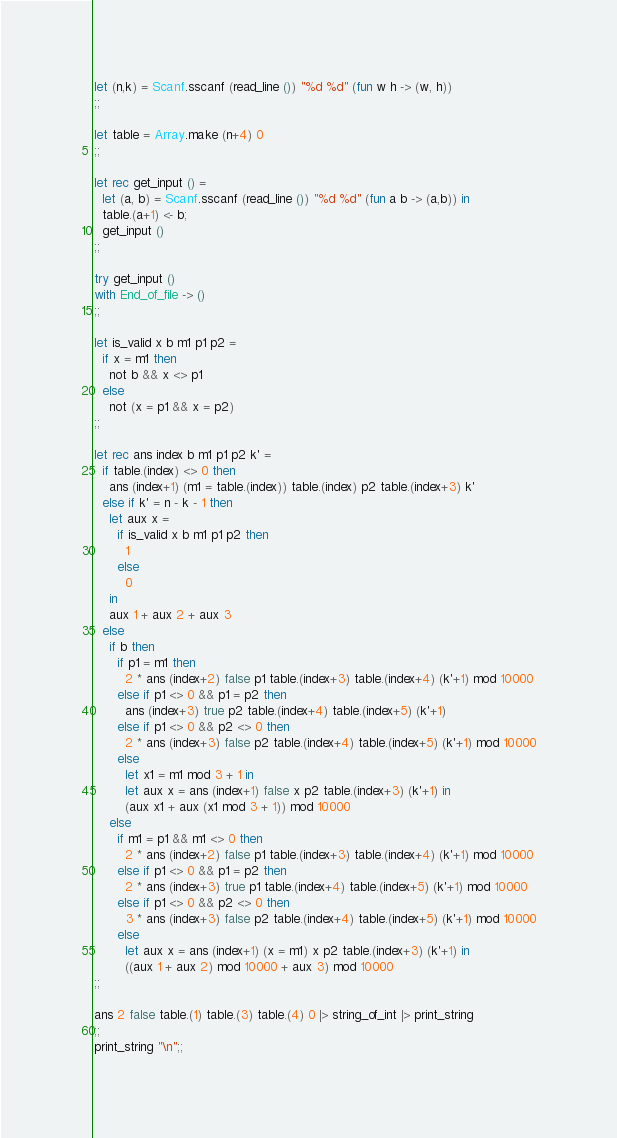Convert code to text. <code><loc_0><loc_0><loc_500><loc_500><_OCaml_>
let (n,k) = Scanf.sscanf (read_line ()) "%d %d" (fun w h -> (w, h))
;;

let table = Array.make (n+4) 0
;;

let rec get_input () =
  let (a, b) = Scanf.sscanf (read_line ()) "%d %d" (fun a b -> (a,b)) in
  table.(a+1) <- b;
  get_input ()
;;

try get_input ()
with End_of_file -> ()
;;

let is_valid x b m1 p1 p2 =
  if x = m1 then
    not b && x <> p1
  else
    not (x = p1 && x = p2)
;;

let rec ans index b m1 p1 p2 k' =
  if table.(index) <> 0 then
    ans (index+1) (m1 = table.(index)) table.(index) p2 table.(index+3) k'
  else if k' = n - k - 1 then
    let aux x =
      if is_valid x b m1 p1 p2 then
        1
      else
        0
    in
    aux 1 + aux 2 + aux 3
  else
    if b then
      if p1 = m1 then
        2 * ans (index+2) false p1 table.(index+3) table.(index+4) (k'+1) mod 10000
      else if p1 <> 0 && p1 = p2 then
        ans (index+3) true p2 table.(index+4) table.(index+5) (k'+1)
      else if p1 <> 0 && p2 <> 0 then
        2 * ans (index+3) false p2 table.(index+4) table.(index+5) (k'+1) mod 10000
      else
        let x1 = m1 mod 3 + 1 in
        let aux x = ans (index+1) false x p2 table.(index+3) (k'+1) in
        (aux x1 + aux (x1 mod 3 + 1)) mod 10000
    else
      if m1 = p1 && m1 <> 0 then
        2 * ans (index+2) false p1 table.(index+3) table.(index+4) (k'+1) mod 10000
      else if p1 <> 0 && p1 = p2 then
        2 * ans (index+3) true p1 table.(index+4) table.(index+5) (k'+1) mod 10000
      else if p1 <> 0 && p2 <> 0 then
        3 * ans (index+3) false p2 table.(index+4) table.(index+5) (k'+1) mod 10000
      else
        let aux x = ans (index+1) (x = m1) x p2 table.(index+3) (k'+1) in
        ((aux 1 + aux 2) mod 10000 + aux 3) mod 10000
;;

ans 2 false table.(1) table.(3) table.(4) 0 |> string_of_int |> print_string
;;
print_string "\n";;

</code> 